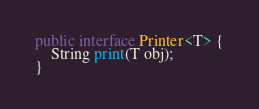Convert code to text. <code><loc_0><loc_0><loc_500><loc_500><_Java_>public interface Printer<T> {
    String print(T obj);
}
</code> 